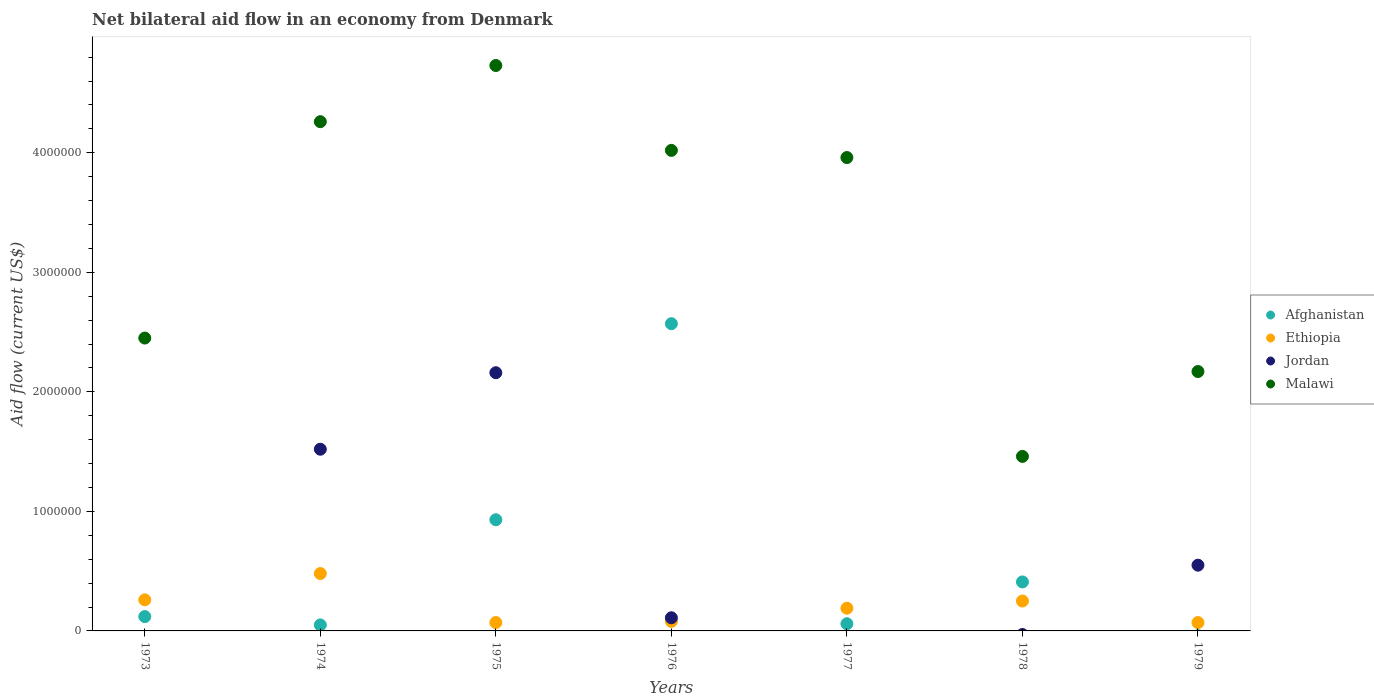Is the number of dotlines equal to the number of legend labels?
Provide a succinct answer. No. What is the net bilateral aid flow in Malawi in 1974?
Your answer should be compact. 4.26e+06. Across all years, what is the maximum net bilateral aid flow in Afghanistan?
Offer a very short reply. 2.57e+06. In which year was the net bilateral aid flow in Jordan maximum?
Ensure brevity in your answer.  1975. What is the total net bilateral aid flow in Afghanistan in the graph?
Provide a short and direct response. 4.14e+06. What is the difference between the net bilateral aid flow in Malawi in 1978 and that in 1979?
Provide a short and direct response. -7.10e+05. What is the difference between the net bilateral aid flow in Malawi in 1979 and the net bilateral aid flow in Ethiopia in 1977?
Your answer should be compact. 1.98e+06. What is the average net bilateral aid flow in Afghanistan per year?
Your answer should be compact. 5.91e+05. In the year 1976, what is the difference between the net bilateral aid flow in Afghanistan and net bilateral aid flow in Jordan?
Your response must be concise. 2.46e+06. What is the ratio of the net bilateral aid flow in Jordan in 1975 to that in 1976?
Your response must be concise. 19.64. What is the difference between the highest and the lowest net bilateral aid flow in Afghanistan?
Offer a very short reply. 2.57e+06. Is the sum of the net bilateral aid flow in Ethiopia in 1973 and 1978 greater than the maximum net bilateral aid flow in Afghanistan across all years?
Your response must be concise. No. Is the net bilateral aid flow in Ethiopia strictly less than the net bilateral aid flow in Afghanistan over the years?
Provide a short and direct response. No. How many dotlines are there?
Offer a very short reply. 4. Are the values on the major ticks of Y-axis written in scientific E-notation?
Offer a very short reply. No. Does the graph contain any zero values?
Make the answer very short. Yes. Does the graph contain grids?
Offer a terse response. No. Where does the legend appear in the graph?
Your response must be concise. Center right. What is the title of the graph?
Offer a terse response. Net bilateral aid flow in an economy from Denmark. Does "Sub-Saharan Africa (developing only)" appear as one of the legend labels in the graph?
Keep it short and to the point. No. What is the Aid flow (current US$) in Afghanistan in 1973?
Offer a very short reply. 1.20e+05. What is the Aid flow (current US$) of Malawi in 1973?
Make the answer very short. 2.45e+06. What is the Aid flow (current US$) in Jordan in 1974?
Offer a very short reply. 1.52e+06. What is the Aid flow (current US$) of Malawi in 1974?
Offer a very short reply. 4.26e+06. What is the Aid flow (current US$) in Afghanistan in 1975?
Keep it short and to the point. 9.30e+05. What is the Aid flow (current US$) in Jordan in 1975?
Offer a very short reply. 2.16e+06. What is the Aid flow (current US$) of Malawi in 1975?
Provide a succinct answer. 4.73e+06. What is the Aid flow (current US$) in Afghanistan in 1976?
Your answer should be compact. 2.57e+06. What is the Aid flow (current US$) in Ethiopia in 1976?
Offer a very short reply. 8.00e+04. What is the Aid flow (current US$) in Malawi in 1976?
Your response must be concise. 4.02e+06. What is the Aid flow (current US$) in Malawi in 1977?
Your answer should be compact. 3.96e+06. What is the Aid flow (current US$) in Jordan in 1978?
Offer a very short reply. 0. What is the Aid flow (current US$) in Malawi in 1978?
Give a very brief answer. 1.46e+06. What is the Aid flow (current US$) of Afghanistan in 1979?
Your answer should be compact. 0. What is the Aid flow (current US$) in Ethiopia in 1979?
Make the answer very short. 7.00e+04. What is the Aid flow (current US$) of Malawi in 1979?
Your answer should be compact. 2.17e+06. Across all years, what is the maximum Aid flow (current US$) of Afghanistan?
Provide a succinct answer. 2.57e+06. Across all years, what is the maximum Aid flow (current US$) in Ethiopia?
Ensure brevity in your answer.  4.80e+05. Across all years, what is the maximum Aid flow (current US$) of Jordan?
Give a very brief answer. 2.16e+06. Across all years, what is the maximum Aid flow (current US$) in Malawi?
Your answer should be compact. 4.73e+06. Across all years, what is the minimum Aid flow (current US$) of Ethiopia?
Keep it short and to the point. 7.00e+04. Across all years, what is the minimum Aid flow (current US$) in Malawi?
Provide a short and direct response. 1.46e+06. What is the total Aid flow (current US$) of Afghanistan in the graph?
Ensure brevity in your answer.  4.14e+06. What is the total Aid flow (current US$) in Ethiopia in the graph?
Ensure brevity in your answer.  1.40e+06. What is the total Aid flow (current US$) in Jordan in the graph?
Your answer should be very brief. 4.34e+06. What is the total Aid flow (current US$) in Malawi in the graph?
Your answer should be very brief. 2.30e+07. What is the difference between the Aid flow (current US$) in Afghanistan in 1973 and that in 1974?
Provide a succinct answer. 7.00e+04. What is the difference between the Aid flow (current US$) of Ethiopia in 1973 and that in 1974?
Provide a succinct answer. -2.20e+05. What is the difference between the Aid flow (current US$) of Malawi in 1973 and that in 1974?
Make the answer very short. -1.81e+06. What is the difference between the Aid flow (current US$) of Afghanistan in 1973 and that in 1975?
Ensure brevity in your answer.  -8.10e+05. What is the difference between the Aid flow (current US$) in Malawi in 1973 and that in 1975?
Keep it short and to the point. -2.28e+06. What is the difference between the Aid flow (current US$) in Afghanistan in 1973 and that in 1976?
Provide a short and direct response. -2.45e+06. What is the difference between the Aid flow (current US$) of Ethiopia in 1973 and that in 1976?
Give a very brief answer. 1.80e+05. What is the difference between the Aid flow (current US$) of Malawi in 1973 and that in 1976?
Give a very brief answer. -1.57e+06. What is the difference between the Aid flow (current US$) in Afghanistan in 1973 and that in 1977?
Give a very brief answer. 6.00e+04. What is the difference between the Aid flow (current US$) in Malawi in 1973 and that in 1977?
Keep it short and to the point. -1.51e+06. What is the difference between the Aid flow (current US$) in Afghanistan in 1973 and that in 1978?
Provide a succinct answer. -2.90e+05. What is the difference between the Aid flow (current US$) in Ethiopia in 1973 and that in 1978?
Your answer should be very brief. 10000. What is the difference between the Aid flow (current US$) of Malawi in 1973 and that in 1978?
Make the answer very short. 9.90e+05. What is the difference between the Aid flow (current US$) of Malawi in 1973 and that in 1979?
Provide a short and direct response. 2.80e+05. What is the difference between the Aid flow (current US$) of Afghanistan in 1974 and that in 1975?
Keep it short and to the point. -8.80e+05. What is the difference between the Aid flow (current US$) of Ethiopia in 1974 and that in 1975?
Provide a succinct answer. 4.10e+05. What is the difference between the Aid flow (current US$) of Jordan in 1974 and that in 1975?
Keep it short and to the point. -6.40e+05. What is the difference between the Aid flow (current US$) of Malawi in 1974 and that in 1975?
Offer a terse response. -4.70e+05. What is the difference between the Aid flow (current US$) of Afghanistan in 1974 and that in 1976?
Keep it short and to the point. -2.52e+06. What is the difference between the Aid flow (current US$) of Ethiopia in 1974 and that in 1976?
Ensure brevity in your answer.  4.00e+05. What is the difference between the Aid flow (current US$) in Jordan in 1974 and that in 1976?
Offer a very short reply. 1.41e+06. What is the difference between the Aid flow (current US$) in Afghanistan in 1974 and that in 1977?
Provide a short and direct response. -10000. What is the difference between the Aid flow (current US$) in Malawi in 1974 and that in 1977?
Your answer should be very brief. 3.00e+05. What is the difference between the Aid flow (current US$) in Afghanistan in 1974 and that in 1978?
Your answer should be compact. -3.60e+05. What is the difference between the Aid flow (current US$) of Malawi in 1974 and that in 1978?
Offer a very short reply. 2.80e+06. What is the difference between the Aid flow (current US$) of Ethiopia in 1974 and that in 1979?
Offer a terse response. 4.10e+05. What is the difference between the Aid flow (current US$) in Jordan in 1974 and that in 1979?
Make the answer very short. 9.70e+05. What is the difference between the Aid flow (current US$) in Malawi in 1974 and that in 1979?
Provide a short and direct response. 2.09e+06. What is the difference between the Aid flow (current US$) of Afghanistan in 1975 and that in 1976?
Ensure brevity in your answer.  -1.64e+06. What is the difference between the Aid flow (current US$) of Ethiopia in 1975 and that in 1976?
Provide a short and direct response. -10000. What is the difference between the Aid flow (current US$) of Jordan in 1975 and that in 1976?
Your answer should be very brief. 2.05e+06. What is the difference between the Aid flow (current US$) of Malawi in 1975 and that in 1976?
Your response must be concise. 7.10e+05. What is the difference between the Aid flow (current US$) of Afghanistan in 1975 and that in 1977?
Provide a succinct answer. 8.70e+05. What is the difference between the Aid flow (current US$) of Malawi in 1975 and that in 1977?
Your response must be concise. 7.70e+05. What is the difference between the Aid flow (current US$) of Afghanistan in 1975 and that in 1978?
Offer a very short reply. 5.20e+05. What is the difference between the Aid flow (current US$) in Ethiopia in 1975 and that in 1978?
Keep it short and to the point. -1.80e+05. What is the difference between the Aid flow (current US$) of Malawi in 1975 and that in 1978?
Offer a terse response. 3.27e+06. What is the difference between the Aid flow (current US$) in Ethiopia in 1975 and that in 1979?
Provide a short and direct response. 0. What is the difference between the Aid flow (current US$) in Jordan in 1975 and that in 1979?
Keep it short and to the point. 1.61e+06. What is the difference between the Aid flow (current US$) of Malawi in 1975 and that in 1979?
Keep it short and to the point. 2.56e+06. What is the difference between the Aid flow (current US$) of Afghanistan in 1976 and that in 1977?
Make the answer very short. 2.51e+06. What is the difference between the Aid flow (current US$) in Afghanistan in 1976 and that in 1978?
Make the answer very short. 2.16e+06. What is the difference between the Aid flow (current US$) of Malawi in 1976 and that in 1978?
Your response must be concise. 2.56e+06. What is the difference between the Aid flow (current US$) in Jordan in 1976 and that in 1979?
Provide a succinct answer. -4.40e+05. What is the difference between the Aid flow (current US$) in Malawi in 1976 and that in 1979?
Keep it short and to the point. 1.85e+06. What is the difference between the Aid flow (current US$) of Afghanistan in 1977 and that in 1978?
Make the answer very short. -3.50e+05. What is the difference between the Aid flow (current US$) of Malawi in 1977 and that in 1978?
Offer a terse response. 2.50e+06. What is the difference between the Aid flow (current US$) in Ethiopia in 1977 and that in 1979?
Offer a terse response. 1.20e+05. What is the difference between the Aid flow (current US$) in Malawi in 1977 and that in 1979?
Offer a very short reply. 1.79e+06. What is the difference between the Aid flow (current US$) of Ethiopia in 1978 and that in 1979?
Keep it short and to the point. 1.80e+05. What is the difference between the Aid flow (current US$) of Malawi in 1978 and that in 1979?
Your answer should be very brief. -7.10e+05. What is the difference between the Aid flow (current US$) in Afghanistan in 1973 and the Aid flow (current US$) in Ethiopia in 1974?
Offer a very short reply. -3.60e+05. What is the difference between the Aid flow (current US$) in Afghanistan in 1973 and the Aid flow (current US$) in Jordan in 1974?
Offer a terse response. -1.40e+06. What is the difference between the Aid flow (current US$) of Afghanistan in 1973 and the Aid flow (current US$) of Malawi in 1974?
Offer a terse response. -4.14e+06. What is the difference between the Aid flow (current US$) in Ethiopia in 1973 and the Aid flow (current US$) in Jordan in 1974?
Offer a terse response. -1.26e+06. What is the difference between the Aid flow (current US$) in Afghanistan in 1973 and the Aid flow (current US$) in Ethiopia in 1975?
Provide a short and direct response. 5.00e+04. What is the difference between the Aid flow (current US$) in Afghanistan in 1973 and the Aid flow (current US$) in Jordan in 1975?
Ensure brevity in your answer.  -2.04e+06. What is the difference between the Aid flow (current US$) in Afghanistan in 1973 and the Aid flow (current US$) in Malawi in 1975?
Your answer should be very brief. -4.61e+06. What is the difference between the Aid flow (current US$) in Ethiopia in 1973 and the Aid flow (current US$) in Jordan in 1975?
Make the answer very short. -1.90e+06. What is the difference between the Aid flow (current US$) of Ethiopia in 1973 and the Aid flow (current US$) of Malawi in 1975?
Provide a short and direct response. -4.47e+06. What is the difference between the Aid flow (current US$) in Afghanistan in 1973 and the Aid flow (current US$) in Ethiopia in 1976?
Keep it short and to the point. 4.00e+04. What is the difference between the Aid flow (current US$) in Afghanistan in 1973 and the Aid flow (current US$) in Malawi in 1976?
Your response must be concise. -3.90e+06. What is the difference between the Aid flow (current US$) of Ethiopia in 1973 and the Aid flow (current US$) of Jordan in 1976?
Ensure brevity in your answer.  1.50e+05. What is the difference between the Aid flow (current US$) in Ethiopia in 1973 and the Aid flow (current US$) in Malawi in 1976?
Provide a succinct answer. -3.76e+06. What is the difference between the Aid flow (current US$) of Afghanistan in 1973 and the Aid flow (current US$) of Malawi in 1977?
Your answer should be very brief. -3.84e+06. What is the difference between the Aid flow (current US$) in Ethiopia in 1973 and the Aid flow (current US$) in Malawi in 1977?
Your answer should be very brief. -3.70e+06. What is the difference between the Aid flow (current US$) of Afghanistan in 1973 and the Aid flow (current US$) of Ethiopia in 1978?
Your answer should be compact. -1.30e+05. What is the difference between the Aid flow (current US$) of Afghanistan in 1973 and the Aid flow (current US$) of Malawi in 1978?
Give a very brief answer. -1.34e+06. What is the difference between the Aid flow (current US$) of Ethiopia in 1973 and the Aid flow (current US$) of Malawi in 1978?
Ensure brevity in your answer.  -1.20e+06. What is the difference between the Aid flow (current US$) of Afghanistan in 1973 and the Aid flow (current US$) of Jordan in 1979?
Your answer should be very brief. -4.30e+05. What is the difference between the Aid flow (current US$) of Afghanistan in 1973 and the Aid flow (current US$) of Malawi in 1979?
Offer a terse response. -2.05e+06. What is the difference between the Aid flow (current US$) in Ethiopia in 1973 and the Aid flow (current US$) in Malawi in 1979?
Keep it short and to the point. -1.91e+06. What is the difference between the Aid flow (current US$) of Afghanistan in 1974 and the Aid flow (current US$) of Jordan in 1975?
Offer a very short reply. -2.11e+06. What is the difference between the Aid flow (current US$) of Afghanistan in 1974 and the Aid flow (current US$) of Malawi in 1975?
Your answer should be compact. -4.68e+06. What is the difference between the Aid flow (current US$) in Ethiopia in 1974 and the Aid flow (current US$) in Jordan in 1975?
Provide a short and direct response. -1.68e+06. What is the difference between the Aid flow (current US$) in Ethiopia in 1974 and the Aid flow (current US$) in Malawi in 1975?
Keep it short and to the point. -4.25e+06. What is the difference between the Aid flow (current US$) of Jordan in 1974 and the Aid flow (current US$) of Malawi in 1975?
Your answer should be compact. -3.21e+06. What is the difference between the Aid flow (current US$) in Afghanistan in 1974 and the Aid flow (current US$) in Ethiopia in 1976?
Your response must be concise. -3.00e+04. What is the difference between the Aid flow (current US$) in Afghanistan in 1974 and the Aid flow (current US$) in Jordan in 1976?
Provide a succinct answer. -6.00e+04. What is the difference between the Aid flow (current US$) of Afghanistan in 1974 and the Aid flow (current US$) of Malawi in 1976?
Offer a terse response. -3.97e+06. What is the difference between the Aid flow (current US$) of Ethiopia in 1974 and the Aid flow (current US$) of Malawi in 1976?
Offer a terse response. -3.54e+06. What is the difference between the Aid flow (current US$) of Jordan in 1974 and the Aid flow (current US$) of Malawi in 1976?
Your response must be concise. -2.50e+06. What is the difference between the Aid flow (current US$) in Afghanistan in 1974 and the Aid flow (current US$) in Ethiopia in 1977?
Provide a short and direct response. -1.40e+05. What is the difference between the Aid flow (current US$) in Afghanistan in 1974 and the Aid flow (current US$) in Malawi in 1977?
Give a very brief answer. -3.91e+06. What is the difference between the Aid flow (current US$) of Ethiopia in 1974 and the Aid flow (current US$) of Malawi in 1977?
Ensure brevity in your answer.  -3.48e+06. What is the difference between the Aid flow (current US$) of Jordan in 1974 and the Aid flow (current US$) of Malawi in 1977?
Keep it short and to the point. -2.44e+06. What is the difference between the Aid flow (current US$) in Afghanistan in 1974 and the Aid flow (current US$) in Malawi in 1978?
Make the answer very short. -1.41e+06. What is the difference between the Aid flow (current US$) of Ethiopia in 1974 and the Aid flow (current US$) of Malawi in 1978?
Provide a short and direct response. -9.80e+05. What is the difference between the Aid flow (current US$) in Afghanistan in 1974 and the Aid flow (current US$) in Jordan in 1979?
Offer a very short reply. -5.00e+05. What is the difference between the Aid flow (current US$) of Afghanistan in 1974 and the Aid flow (current US$) of Malawi in 1979?
Your answer should be compact. -2.12e+06. What is the difference between the Aid flow (current US$) in Ethiopia in 1974 and the Aid flow (current US$) in Malawi in 1979?
Provide a short and direct response. -1.69e+06. What is the difference between the Aid flow (current US$) of Jordan in 1974 and the Aid flow (current US$) of Malawi in 1979?
Offer a terse response. -6.50e+05. What is the difference between the Aid flow (current US$) of Afghanistan in 1975 and the Aid flow (current US$) of Ethiopia in 1976?
Provide a succinct answer. 8.50e+05. What is the difference between the Aid flow (current US$) of Afghanistan in 1975 and the Aid flow (current US$) of Jordan in 1976?
Give a very brief answer. 8.20e+05. What is the difference between the Aid flow (current US$) of Afghanistan in 1975 and the Aid flow (current US$) of Malawi in 1976?
Your answer should be very brief. -3.09e+06. What is the difference between the Aid flow (current US$) in Ethiopia in 1975 and the Aid flow (current US$) in Malawi in 1976?
Offer a very short reply. -3.95e+06. What is the difference between the Aid flow (current US$) of Jordan in 1975 and the Aid flow (current US$) of Malawi in 1976?
Your answer should be very brief. -1.86e+06. What is the difference between the Aid flow (current US$) in Afghanistan in 1975 and the Aid flow (current US$) in Ethiopia in 1977?
Keep it short and to the point. 7.40e+05. What is the difference between the Aid flow (current US$) in Afghanistan in 1975 and the Aid flow (current US$) in Malawi in 1977?
Your response must be concise. -3.03e+06. What is the difference between the Aid flow (current US$) of Ethiopia in 1975 and the Aid flow (current US$) of Malawi in 1977?
Provide a short and direct response. -3.89e+06. What is the difference between the Aid flow (current US$) in Jordan in 1975 and the Aid flow (current US$) in Malawi in 1977?
Offer a very short reply. -1.80e+06. What is the difference between the Aid flow (current US$) of Afghanistan in 1975 and the Aid flow (current US$) of Ethiopia in 1978?
Give a very brief answer. 6.80e+05. What is the difference between the Aid flow (current US$) in Afghanistan in 1975 and the Aid flow (current US$) in Malawi in 1978?
Ensure brevity in your answer.  -5.30e+05. What is the difference between the Aid flow (current US$) of Ethiopia in 1975 and the Aid flow (current US$) of Malawi in 1978?
Ensure brevity in your answer.  -1.39e+06. What is the difference between the Aid flow (current US$) in Afghanistan in 1975 and the Aid flow (current US$) in Ethiopia in 1979?
Your answer should be compact. 8.60e+05. What is the difference between the Aid flow (current US$) of Afghanistan in 1975 and the Aid flow (current US$) of Malawi in 1979?
Your answer should be compact. -1.24e+06. What is the difference between the Aid flow (current US$) in Ethiopia in 1975 and the Aid flow (current US$) in Jordan in 1979?
Offer a very short reply. -4.80e+05. What is the difference between the Aid flow (current US$) of Ethiopia in 1975 and the Aid flow (current US$) of Malawi in 1979?
Keep it short and to the point. -2.10e+06. What is the difference between the Aid flow (current US$) of Afghanistan in 1976 and the Aid flow (current US$) of Ethiopia in 1977?
Your answer should be compact. 2.38e+06. What is the difference between the Aid flow (current US$) of Afghanistan in 1976 and the Aid flow (current US$) of Malawi in 1977?
Provide a succinct answer. -1.39e+06. What is the difference between the Aid flow (current US$) in Ethiopia in 1976 and the Aid flow (current US$) in Malawi in 1977?
Make the answer very short. -3.88e+06. What is the difference between the Aid flow (current US$) of Jordan in 1976 and the Aid flow (current US$) of Malawi in 1977?
Make the answer very short. -3.85e+06. What is the difference between the Aid flow (current US$) in Afghanistan in 1976 and the Aid flow (current US$) in Ethiopia in 1978?
Your answer should be compact. 2.32e+06. What is the difference between the Aid flow (current US$) in Afghanistan in 1976 and the Aid flow (current US$) in Malawi in 1978?
Keep it short and to the point. 1.11e+06. What is the difference between the Aid flow (current US$) in Ethiopia in 1976 and the Aid flow (current US$) in Malawi in 1978?
Give a very brief answer. -1.38e+06. What is the difference between the Aid flow (current US$) in Jordan in 1976 and the Aid flow (current US$) in Malawi in 1978?
Your answer should be compact. -1.35e+06. What is the difference between the Aid flow (current US$) in Afghanistan in 1976 and the Aid flow (current US$) in Ethiopia in 1979?
Ensure brevity in your answer.  2.50e+06. What is the difference between the Aid flow (current US$) in Afghanistan in 1976 and the Aid flow (current US$) in Jordan in 1979?
Give a very brief answer. 2.02e+06. What is the difference between the Aid flow (current US$) of Afghanistan in 1976 and the Aid flow (current US$) of Malawi in 1979?
Your answer should be very brief. 4.00e+05. What is the difference between the Aid flow (current US$) in Ethiopia in 1976 and the Aid flow (current US$) in Jordan in 1979?
Your answer should be compact. -4.70e+05. What is the difference between the Aid flow (current US$) in Ethiopia in 1976 and the Aid flow (current US$) in Malawi in 1979?
Offer a terse response. -2.09e+06. What is the difference between the Aid flow (current US$) in Jordan in 1976 and the Aid flow (current US$) in Malawi in 1979?
Your response must be concise. -2.06e+06. What is the difference between the Aid flow (current US$) in Afghanistan in 1977 and the Aid flow (current US$) in Ethiopia in 1978?
Offer a terse response. -1.90e+05. What is the difference between the Aid flow (current US$) of Afghanistan in 1977 and the Aid flow (current US$) of Malawi in 1978?
Provide a succinct answer. -1.40e+06. What is the difference between the Aid flow (current US$) of Ethiopia in 1977 and the Aid flow (current US$) of Malawi in 1978?
Provide a short and direct response. -1.27e+06. What is the difference between the Aid flow (current US$) in Afghanistan in 1977 and the Aid flow (current US$) in Jordan in 1979?
Your answer should be compact. -4.90e+05. What is the difference between the Aid flow (current US$) of Afghanistan in 1977 and the Aid flow (current US$) of Malawi in 1979?
Your answer should be compact. -2.11e+06. What is the difference between the Aid flow (current US$) of Ethiopia in 1977 and the Aid flow (current US$) of Jordan in 1979?
Your answer should be compact. -3.60e+05. What is the difference between the Aid flow (current US$) of Ethiopia in 1977 and the Aid flow (current US$) of Malawi in 1979?
Offer a terse response. -1.98e+06. What is the difference between the Aid flow (current US$) in Afghanistan in 1978 and the Aid flow (current US$) in Malawi in 1979?
Your answer should be very brief. -1.76e+06. What is the difference between the Aid flow (current US$) in Ethiopia in 1978 and the Aid flow (current US$) in Jordan in 1979?
Give a very brief answer. -3.00e+05. What is the difference between the Aid flow (current US$) in Ethiopia in 1978 and the Aid flow (current US$) in Malawi in 1979?
Make the answer very short. -1.92e+06. What is the average Aid flow (current US$) of Afghanistan per year?
Your response must be concise. 5.91e+05. What is the average Aid flow (current US$) in Jordan per year?
Provide a short and direct response. 6.20e+05. What is the average Aid flow (current US$) of Malawi per year?
Provide a succinct answer. 3.29e+06. In the year 1973, what is the difference between the Aid flow (current US$) of Afghanistan and Aid flow (current US$) of Malawi?
Make the answer very short. -2.33e+06. In the year 1973, what is the difference between the Aid flow (current US$) in Ethiopia and Aid flow (current US$) in Malawi?
Keep it short and to the point. -2.19e+06. In the year 1974, what is the difference between the Aid flow (current US$) of Afghanistan and Aid flow (current US$) of Ethiopia?
Your response must be concise. -4.30e+05. In the year 1974, what is the difference between the Aid flow (current US$) of Afghanistan and Aid flow (current US$) of Jordan?
Your answer should be compact. -1.47e+06. In the year 1974, what is the difference between the Aid flow (current US$) in Afghanistan and Aid flow (current US$) in Malawi?
Offer a terse response. -4.21e+06. In the year 1974, what is the difference between the Aid flow (current US$) in Ethiopia and Aid flow (current US$) in Jordan?
Keep it short and to the point. -1.04e+06. In the year 1974, what is the difference between the Aid flow (current US$) in Ethiopia and Aid flow (current US$) in Malawi?
Ensure brevity in your answer.  -3.78e+06. In the year 1974, what is the difference between the Aid flow (current US$) of Jordan and Aid flow (current US$) of Malawi?
Your response must be concise. -2.74e+06. In the year 1975, what is the difference between the Aid flow (current US$) in Afghanistan and Aid flow (current US$) in Ethiopia?
Your answer should be compact. 8.60e+05. In the year 1975, what is the difference between the Aid flow (current US$) of Afghanistan and Aid flow (current US$) of Jordan?
Offer a very short reply. -1.23e+06. In the year 1975, what is the difference between the Aid flow (current US$) in Afghanistan and Aid flow (current US$) in Malawi?
Provide a short and direct response. -3.80e+06. In the year 1975, what is the difference between the Aid flow (current US$) of Ethiopia and Aid flow (current US$) of Jordan?
Give a very brief answer. -2.09e+06. In the year 1975, what is the difference between the Aid flow (current US$) in Ethiopia and Aid flow (current US$) in Malawi?
Provide a short and direct response. -4.66e+06. In the year 1975, what is the difference between the Aid flow (current US$) of Jordan and Aid flow (current US$) of Malawi?
Keep it short and to the point. -2.57e+06. In the year 1976, what is the difference between the Aid flow (current US$) in Afghanistan and Aid flow (current US$) in Ethiopia?
Offer a terse response. 2.49e+06. In the year 1976, what is the difference between the Aid flow (current US$) of Afghanistan and Aid flow (current US$) of Jordan?
Your response must be concise. 2.46e+06. In the year 1976, what is the difference between the Aid flow (current US$) of Afghanistan and Aid flow (current US$) of Malawi?
Make the answer very short. -1.45e+06. In the year 1976, what is the difference between the Aid flow (current US$) of Ethiopia and Aid flow (current US$) of Malawi?
Ensure brevity in your answer.  -3.94e+06. In the year 1976, what is the difference between the Aid flow (current US$) of Jordan and Aid flow (current US$) of Malawi?
Your answer should be compact. -3.91e+06. In the year 1977, what is the difference between the Aid flow (current US$) of Afghanistan and Aid flow (current US$) of Malawi?
Provide a short and direct response. -3.90e+06. In the year 1977, what is the difference between the Aid flow (current US$) of Ethiopia and Aid flow (current US$) of Malawi?
Keep it short and to the point. -3.77e+06. In the year 1978, what is the difference between the Aid flow (current US$) in Afghanistan and Aid flow (current US$) in Malawi?
Make the answer very short. -1.05e+06. In the year 1978, what is the difference between the Aid flow (current US$) of Ethiopia and Aid flow (current US$) of Malawi?
Give a very brief answer. -1.21e+06. In the year 1979, what is the difference between the Aid flow (current US$) of Ethiopia and Aid flow (current US$) of Jordan?
Your response must be concise. -4.80e+05. In the year 1979, what is the difference between the Aid flow (current US$) of Ethiopia and Aid flow (current US$) of Malawi?
Make the answer very short. -2.10e+06. In the year 1979, what is the difference between the Aid flow (current US$) of Jordan and Aid flow (current US$) of Malawi?
Your answer should be compact. -1.62e+06. What is the ratio of the Aid flow (current US$) in Ethiopia in 1973 to that in 1974?
Provide a succinct answer. 0.54. What is the ratio of the Aid flow (current US$) in Malawi in 1973 to that in 1974?
Provide a succinct answer. 0.58. What is the ratio of the Aid flow (current US$) of Afghanistan in 1973 to that in 1975?
Your response must be concise. 0.13. What is the ratio of the Aid flow (current US$) of Ethiopia in 1973 to that in 1975?
Give a very brief answer. 3.71. What is the ratio of the Aid flow (current US$) of Malawi in 1973 to that in 1975?
Provide a short and direct response. 0.52. What is the ratio of the Aid flow (current US$) in Afghanistan in 1973 to that in 1976?
Provide a short and direct response. 0.05. What is the ratio of the Aid flow (current US$) of Malawi in 1973 to that in 1976?
Provide a short and direct response. 0.61. What is the ratio of the Aid flow (current US$) in Afghanistan in 1973 to that in 1977?
Your response must be concise. 2. What is the ratio of the Aid flow (current US$) of Ethiopia in 1973 to that in 1977?
Your response must be concise. 1.37. What is the ratio of the Aid flow (current US$) of Malawi in 1973 to that in 1977?
Provide a short and direct response. 0.62. What is the ratio of the Aid flow (current US$) of Afghanistan in 1973 to that in 1978?
Offer a very short reply. 0.29. What is the ratio of the Aid flow (current US$) in Malawi in 1973 to that in 1978?
Ensure brevity in your answer.  1.68. What is the ratio of the Aid flow (current US$) of Ethiopia in 1973 to that in 1979?
Make the answer very short. 3.71. What is the ratio of the Aid flow (current US$) in Malawi in 1973 to that in 1979?
Keep it short and to the point. 1.13. What is the ratio of the Aid flow (current US$) in Afghanistan in 1974 to that in 1975?
Offer a very short reply. 0.05. What is the ratio of the Aid flow (current US$) in Ethiopia in 1974 to that in 1975?
Keep it short and to the point. 6.86. What is the ratio of the Aid flow (current US$) in Jordan in 1974 to that in 1975?
Provide a succinct answer. 0.7. What is the ratio of the Aid flow (current US$) in Malawi in 1974 to that in 1975?
Ensure brevity in your answer.  0.9. What is the ratio of the Aid flow (current US$) in Afghanistan in 1974 to that in 1976?
Keep it short and to the point. 0.02. What is the ratio of the Aid flow (current US$) of Ethiopia in 1974 to that in 1976?
Provide a short and direct response. 6. What is the ratio of the Aid flow (current US$) of Jordan in 1974 to that in 1976?
Provide a short and direct response. 13.82. What is the ratio of the Aid flow (current US$) in Malawi in 1974 to that in 1976?
Offer a very short reply. 1.06. What is the ratio of the Aid flow (current US$) in Afghanistan in 1974 to that in 1977?
Your answer should be very brief. 0.83. What is the ratio of the Aid flow (current US$) in Ethiopia in 1974 to that in 1977?
Provide a succinct answer. 2.53. What is the ratio of the Aid flow (current US$) of Malawi in 1974 to that in 1977?
Offer a terse response. 1.08. What is the ratio of the Aid flow (current US$) of Afghanistan in 1974 to that in 1978?
Your response must be concise. 0.12. What is the ratio of the Aid flow (current US$) of Ethiopia in 1974 to that in 1978?
Provide a short and direct response. 1.92. What is the ratio of the Aid flow (current US$) of Malawi in 1974 to that in 1978?
Provide a succinct answer. 2.92. What is the ratio of the Aid flow (current US$) in Ethiopia in 1974 to that in 1979?
Your answer should be very brief. 6.86. What is the ratio of the Aid flow (current US$) of Jordan in 1974 to that in 1979?
Keep it short and to the point. 2.76. What is the ratio of the Aid flow (current US$) of Malawi in 1974 to that in 1979?
Provide a succinct answer. 1.96. What is the ratio of the Aid flow (current US$) of Afghanistan in 1975 to that in 1976?
Ensure brevity in your answer.  0.36. What is the ratio of the Aid flow (current US$) in Jordan in 1975 to that in 1976?
Ensure brevity in your answer.  19.64. What is the ratio of the Aid flow (current US$) in Malawi in 1975 to that in 1976?
Give a very brief answer. 1.18. What is the ratio of the Aid flow (current US$) in Afghanistan in 1975 to that in 1977?
Offer a very short reply. 15.5. What is the ratio of the Aid flow (current US$) of Ethiopia in 1975 to that in 1977?
Provide a succinct answer. 0.37. What is the ratio of the Aid flow (current US$) in Malawi in 1975 to that in 1977?
Provide a short and direct response. 1.19. What is the ratio of the Aid flow (current US$) of Afghanistan in 1975 to that in 1978?
Offer a terse response. 2.27. What is the ratio of the Aid flow (current US$) of Ethiopia in 1975 to that in 1978?
Keep it short and to the point. 0.28. What is the ratio of the Aid flow (current US$) in Malawi in 1975 to that in 1978?
Provide a succinct answer. 3.24. What is the ratio of the Aid flow (current US$) in Ethiopia in 1975 to that in 1979?
Offer a very short reply. 1. What is the ratio of the Aid flow (current US$) in Jordan in 1975 to that in 1979?
Provide a succinct answer. 3.93. What is the ratio of the Aid flow (current US$) of Malawi in 1975 to that in 1979?
Your response must be concise. 2.18. What is the ratio of the Aid flow (current US$) in Afghanistan in 1976 to that in 1977?
Keep it short and to the point. 42.83. What is the ratio of the Aid flow (current US$) in Ethiopia in 1976 to that in 1977?
Keep it short and to the point. 0.42. What is the ratio of the Aid flow (current US$) of Malawi in 1976 to that in 1977?
Your answer should be compact. 1.02. What is the ratio of the Aid flow (current US$) in Afghanistan in 1976 to that in 1978?
Offer a very short reply. 6.27. What is the ratio of the Aid flow (current US$) in Ethiopia in 1976 to that in 1978?
Your response must be concise. 0.32. What is the ratio of the Aid flow (current US$) of Malawi in 1976 to that in 1978?
Your answer should be compact. 2.75. What is the ratio of the Aid flow (current US$) in Ethiopia in 1976 to that in 1979?
Your answer should be very brief. 1.14. What is the ratio of the Aid flow (current US$) in Malawi in 1976 to that in 1979?
Your answer should be very brief. 1.85. What is the ratio of the Aid flow (current US$) of Afghanistan in 1977 to that in 1978?
Make the answer very short. 0.15. What is the ratio of the Aid flow (current US$) in Ethiopia in 1977 to that in 1978?
Ensure brevity in your answer.  0.76. What is the ratio of the Aid flow (current US$) in Malawi in 1977 to that in 1978?
Provide a short and direct response. 2.71. What is the ratio of the Aid flow (current US$) of Ethiopia in 1977 to that in 1979?
Provide a succinct answer. 2.71. What is the ratio of the Aid flow (current US$) in Malawi in 1977 to that in 1979?
Keep it short and to the point. 1.82. What is the ratio of the Aid flow (current US$) of Ethiopia in 1978 to that in 1979?
Offer a very short reply. 3.57. What is the ratio of the Aid flow (current US$) of Malawi in 1978 to that in 1979?
Your answer should be compact. 0.67. What is the difference between the highest and the second highest Aid flow (current US$) of Afghanistan?
Give a very brief answer. 1.64e+06. What is the difference between the highest and the second highest Aid flow (current US$) of Jordan?
Make the answer very short. 6.40e+05. What is the difference between the highest and the lowest Aid flow (current US$) in Afghanistan?
Your response must be concise. 2.57e+06. What is the difference between the highest and the lowest Aid flow (current US$) in Jordan?
Provide a short and direct response. 2.16e+06. What is the difference between the highest and the lowest Aid flow (current US$) in Malawi?
Your answer should be very brief. 3.27e+06. 